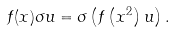<formula> <loc_0><loc_0><loc_500><loc_500>f ( x ) \sigma u = \sigma \left ( f \left ( x ^ { 2 } \right ) u \right ) .</formula> 